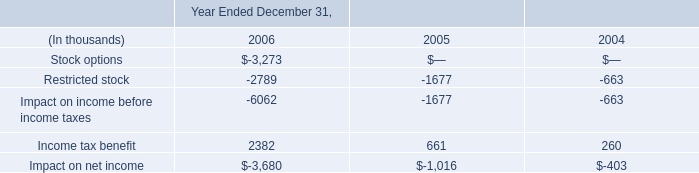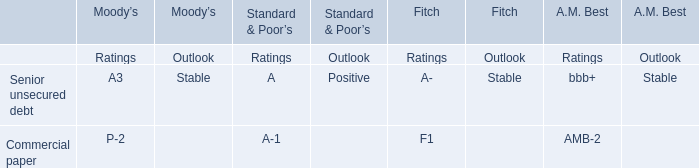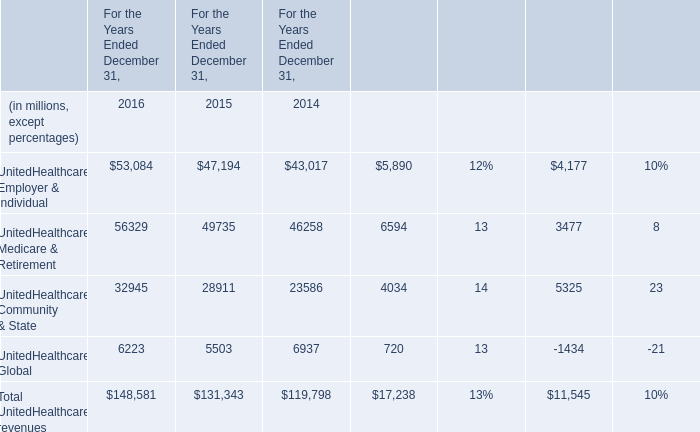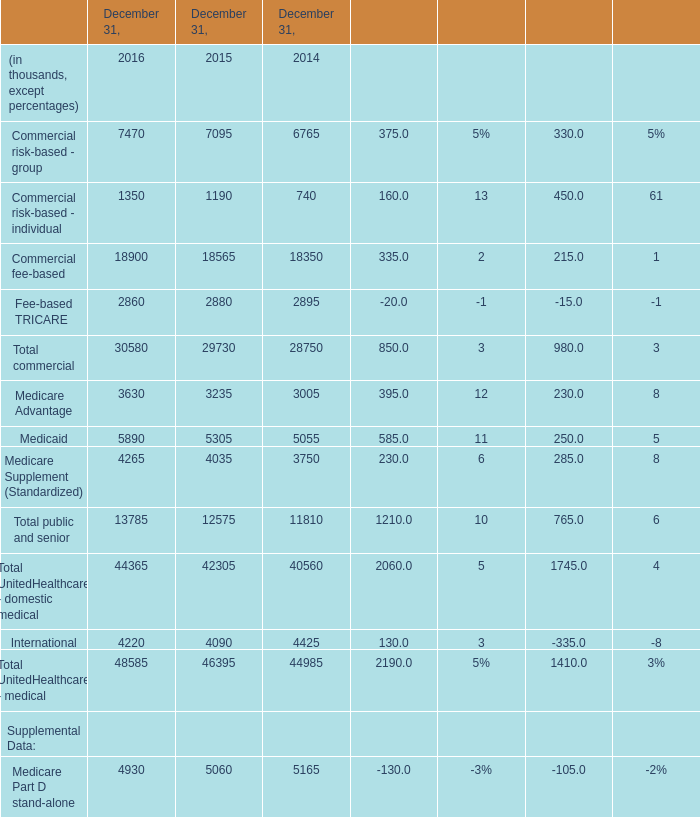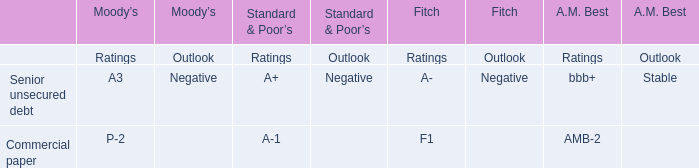As As the chart 3 shows,which year is the amount for Total commercial on December 31 the highest? 
Answer: 2016. 